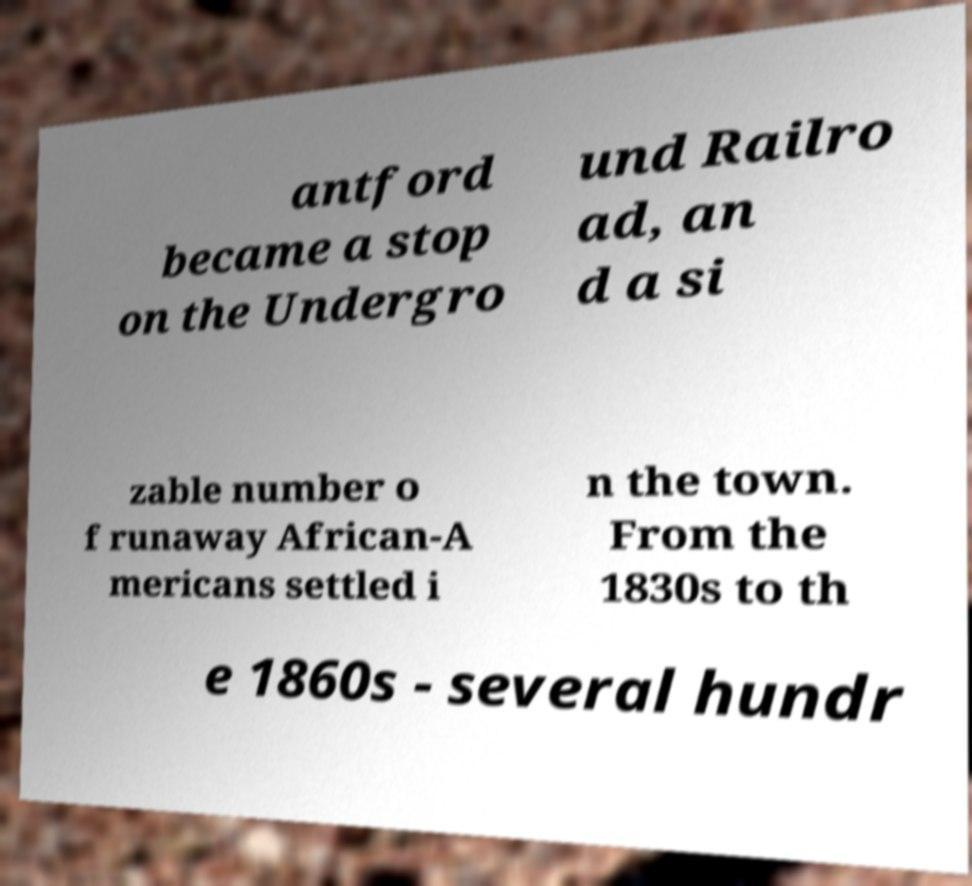Please read and relay the text visible in this image. What does it say? antford became a stop on the Undergro und Railro ad, an d a si zable number o f runaway African-A mericans settled i n the town. From the 1830s to th e 1860s - several hundr 